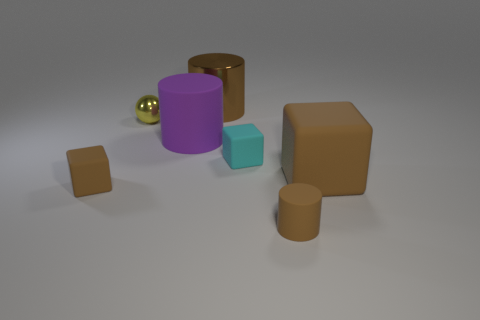There is a rubber thing that is behind the big brown rubber thing and left of the tiny cyan block; what is its size?
Offer a terse response. Large. There is a thing that is both in front of the big cube and to the right of the cyan matte object; what color is it?
Offer a very short reply. Brown. Is there anything else that has the same material as the big purple thing?
Provide a succinct answer. Yes. Is the number of rubber cubes behind the tiny brown matte cube less than the number of cyan rubber blocks that are in front of the large brown rubber thing?
Ensure brevity in your answer.  No. Is there anything else that is the same color as the tiny metal thing?
Provide a short and direct response. No. The cyan matte object has what shape?
Offer a very short reply. Cube. There is another cylinder that is made of the same material as the small cylinder; what is its color?
Offer a very short reply. Purple. Is the number of small cyan things greater than the number of big cyan objects?
Offer a terse response. Yes. Is there a matte cylinder?
Keep it short and to the point. Yes. The brown object that is behind the rubber cylinder that is behind the small cylinder is what shape?
Offer a terse response. Cylinder. 